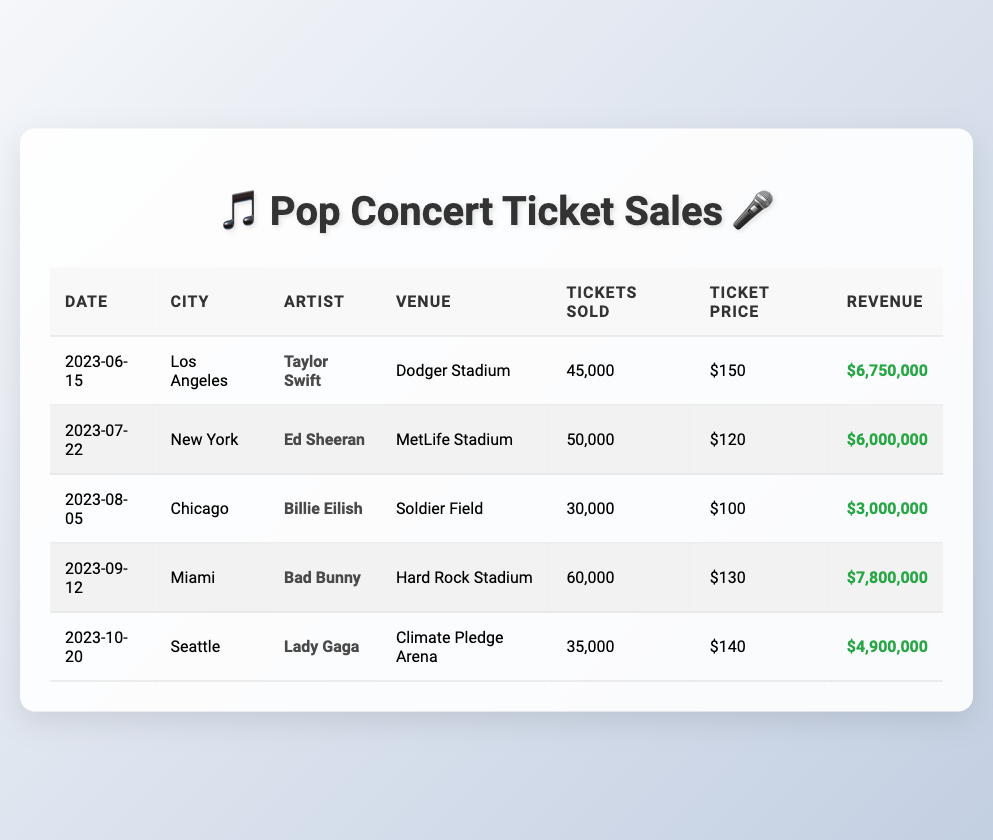What is the total number of tickets sold across all concerts listed? To find the total number of tickets sold, we add up the tickets sold for each concert: 45000 (Los Angeles) + 50000 (New York) + 30000 (Chicago) + 60000 (Miami) + 35000 (Seattle) = 220000.
Answer: 220000 Which artist had the highest ticket sales and how many tickets were sold? By checking the “Tickets Sold” column, we find that Bad Bunny (Miami) sold the most tickets, totaling 60000.
Answer: Bad Bunny, 60000 What is the average ticket price across all concerts? To calculate the average ticket price, we sum the ticket prices: 150 (Los Angeles) + 120 (New York) + 100 (Chicago) + 130 (Miami) + 140 (Seattle) = 740. Then, we divide by the number of concerts: 740 / 5 = 148.
Answer: 148 Did all concerts occur in a single month? By looking at the “Date” column, we see that the concerts are on different dates from June to October, hence they do not all occur in one month.
Answer: No What city had the second highest revenue and how much was it? From the revenue data, we see Miami generated 7800000 (highest), followed by Los Angeles with 6750000. Hence, the second-higest city is Los Angeles.
Answer: Los Angeles, 6750000 How much revenue was generated by concerts held in July and September combined? We identify the revenues for July (New York: 6000000) and September (Miami: 7800000). Adding them gives: 6000000 + 7800000 = 13800000.
Answer: 13800000 Was there a concert in Seattle, and what was the total revenue from that event? Checking the “City” column, Seattle is listed, and in the corresponding row under “Revenue,” it shows 4900000.
Answer: Yes, 4900000 What percentage of total tickets sold were from the concert in Miami? To find the percentage, we take Miami’s tickets sold (60000) and divide it by the total number of tickets sold (220000), then multiply by 100: (60000 / 220000) * 100 = 27.27%.
Answer: 27.27% Which artist performed at Soldier Field? Referring to the “Venue” column, it shows that Soldier Field hosted Billie Eilish.
Answer: Billie Eilish 